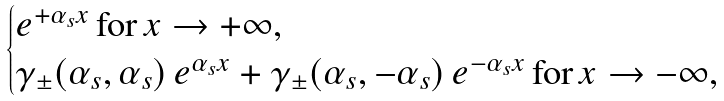Convert formula to latex. <formula><loc_0><loc_0><loc_500><loc_500>\begin{cases} e ^ { + \alpha _ { s } x } \, \text {for} \, x \rightarrow + \infty , \\ \gamma _ { \pm } ( \alpha _ { s } , \alpha _ { s } ) \, e ^ { \alpha _ { s } x } + \gamma _ { \pm } ( \alpha _ { s } , - \alpha _ { s } ) \, e ^ { - \alpha _ { s } x } \, \text {for} \, x \rightarrow - \infty , \end{cases}</formula> 